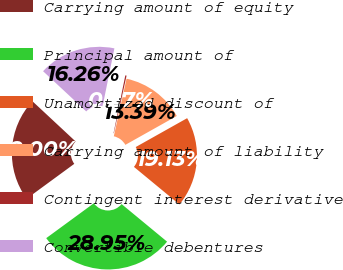<chart> <loc_0><loc_0><loc_500><loc_500><pie_chart><fcel>Carrying amount of equity<fcel>Principal amount of<fcel>Unamortized discount of<fcel>Carrying amount of liability<fcel>Contingent interest derivative<fcel>Convertible debentures<nl><fcel>22.0%<fcel>28.95%<fcel>19.13%<fcel>13.39%<fcel>0.27%<fcel>16.26%<nl></chart> 